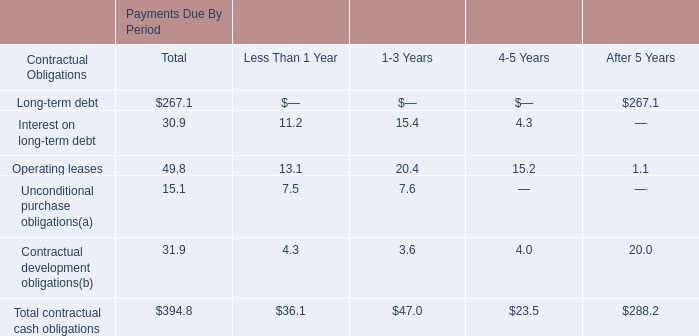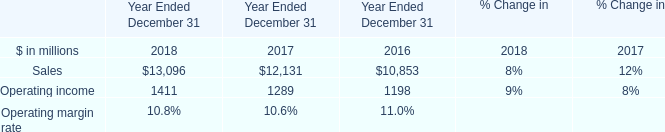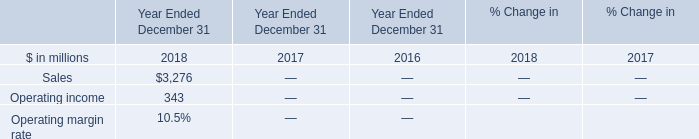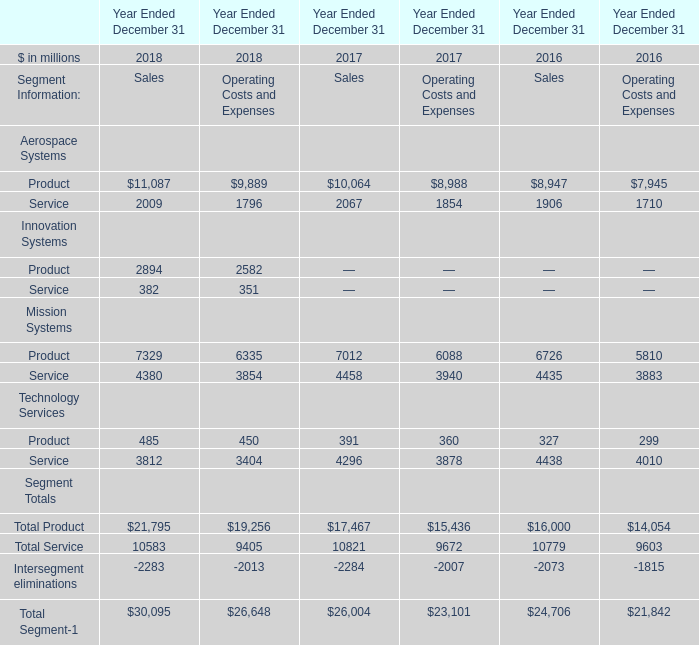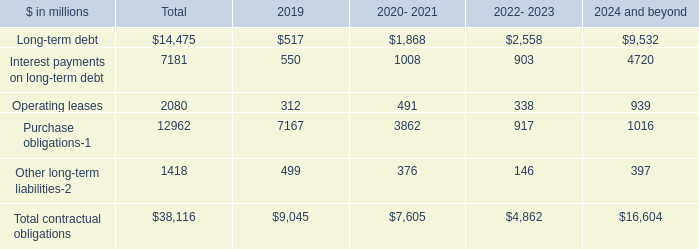What is the sum of Operating leases in 2019 and Sales in 2018? 
Computations: (312 + 3276)
Answer: 3588.0. 